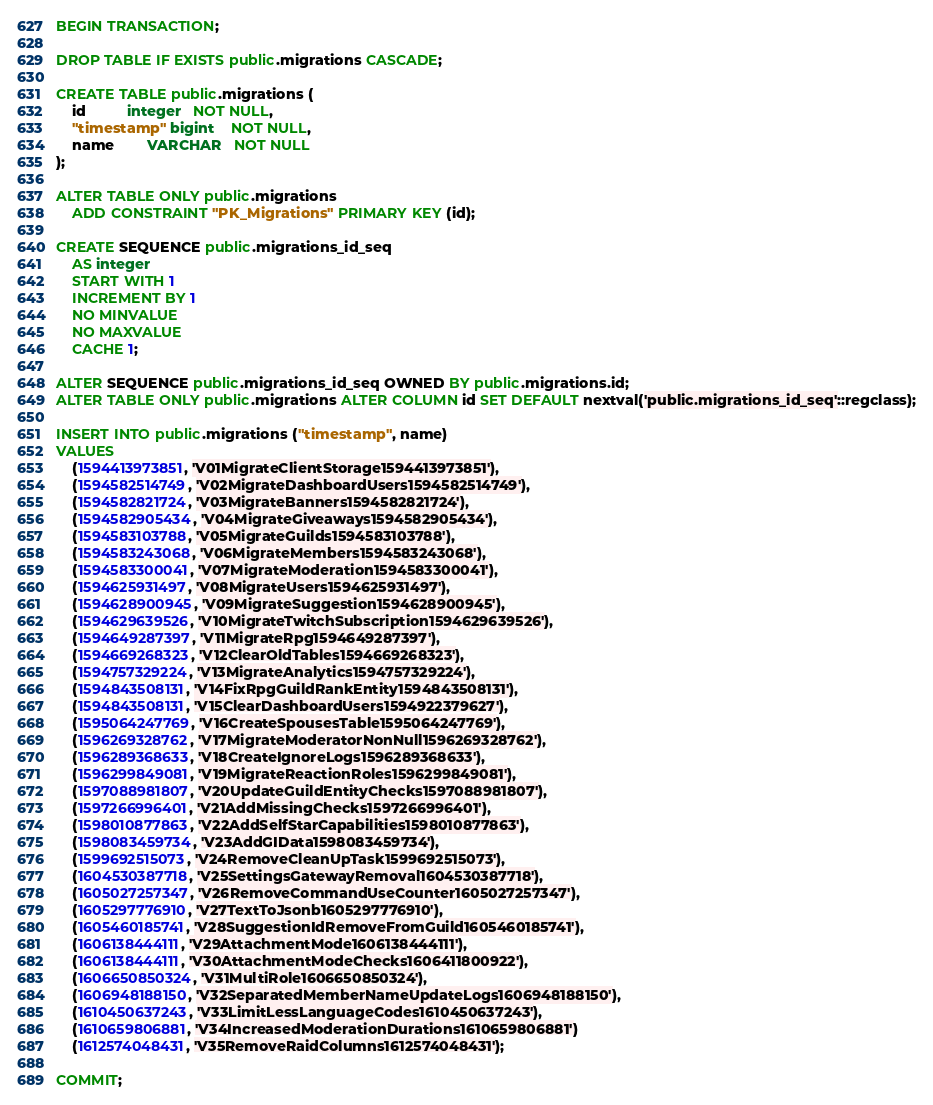<code> <loc_0><loc_0><loc_500><loc_500><_SQL_>BEGIN TRANSACTION;

DROP TABLE IF EXISTS public.migrations CASCADE;

CREATE TABLE public.migrations (
    id          integer   NOT NULL,
    "timestamp" bigint    NOT NULL,
    name        VARCHAR   NOT NULL
);

ALTER TABLE ONLY public.migrations
    ADD CONSTRAINT "PK_Migrations" PRIMARY KEY (id);

CREATE SEQUENCE public.migrations_id_seq
    AS integer
    START WITH 1
    INCREMENT BY 1
    NO MINVALUE
    NO MAXVALUE
    CACHE 1;

ALTER SEQUENCE public.migrations_id_seq OWNED BY public.migrations.id;
ALTER TABLE ONLY public.migrations ALTER COLUMN id SET DEFAULT nextval('public.migrations_id_seq'::regclass);

INSERT INTO public.migrations ("timestamp", name)
VALUES
	(1594413973851, 'V01MigrateClientStorage1594413973851'),
	(1594582514749, 'V02MigrateDashboardUsers1594582514749'),
	(1594582821724, 'V03MigrateBanners1594582821724'),
	(1594582905434, 'V04MigrateGiveaways1594582905434'),
	(1594583103788, 'V05MigrateGuilds1594583103788'),
	(1594583243068, 'V06MigrateMembers1594583243068'),
	(1594583300041, 'V07MigrateModeration1594583300041'),
	(1594625931497, 'V08MigrateUsers1594625931497'),
	(1594628900945, 'V09MigrateSuggestion1594628900945'),
	(1594629639526, 'V10MigrateTwitchSubscription1594629639526'),
	(1594649287397, 'V11MigrateRpg1594649287397'),
	(1594669268323, 'V12ClearOldTables1594669268323'),
	(1594757329224, 'V13MigrateAnalytics1594757329224'),
	(1594843508131, 'V14FixRpgGuildRankEntity1594843508131'),
	(1594843508131, 'V15ClearDashboardUsers1594922379627'),
	(1595064247769, 'V16CreateSpousesTable1595064247769'),
	(1596269328762, 'V17MigrateModeratorNonNull1596269328762'),
	(1596289368633, 'V18CreateIgnoreLogs1596289368633'),
	(1596299849081, 'V19MigrateReactionRoles1596299849081'),
	(1597088981807, 'V20UpdateGuildEntityChecks1597088981807'),
	(1597266996401, 'V21AddMissingChecks1597266996401'),
	(1598010877863, 'V22AddSelfStarCapabilities1598010877863'),
	(1598083459734, 'V23AddGIData1598083459734'),
	(1599692515073, 'V24RemoveCleanUpTask1599692515073'),
	(1604530387718, 'V25SettingsGatewayRemoval1604530387718'),
	(1605027257347, 'V26RemoveCommandUseCounter1605027257347'),
	(1605297776910, 'V27TextToJsonb1605297776910'),
	(1605460185741, 'V28SuggestionIdRemoveFromGuild1605460185741'),
	(1606138444111, 'V29AttachmentMode1606138444111'),
	(1606138444111, 'V30AttachmentModeChecks1606411800922'),
	(1606650850324, 'V31MultiRole1606650850324'),
	(1606948188150, 'V32SeparatedMemberNameUpdateLogs1606948188150'),
	(1610450637243, 'V33LimitLessLanguageCodes1610450637243'),
	(1610659806881, 'V34IncreasedModerationDurations1610659806881')
	(1612574048431, 'V35RemoveRaidColumns1612574048431');

COMMIT;
</code> 